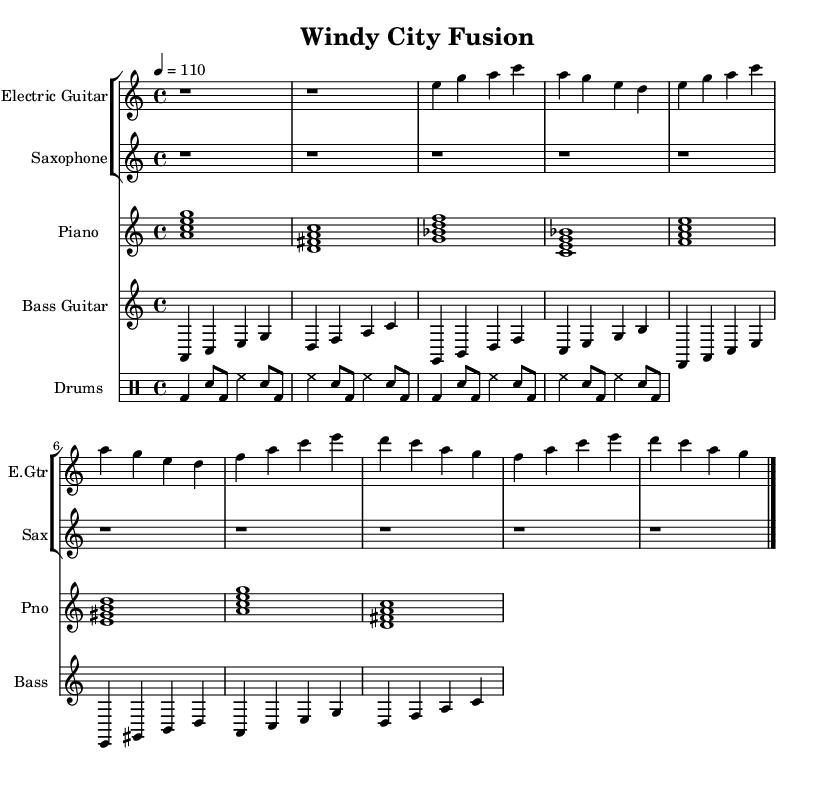What is the key signature of this music? The key signature is A minor, which is represented in the sheet music with no sharps or flats. It can be identified by looking at the global settings at the beginning of the code where it states " \key a \minor".
Answer: A minor What is the time signature of this music? The time signature is 4/4, indicated by " \time 4/4" in the global setup. This means there are four beats in each measure and the quarter note gets one beat.
Answer: 4/4 What is the tempo of this piece? The tempo is marked at 110 beats per minute, shown as " \tempo 4 = 110" in the code. This indicates a moderately fast pace for the music.
Answer: 110 How many measures are there in the electric guitar part? The electric guitar part consists of four measures in both the verse and chorus sections, totaling eight measures. The sections are clearly marked in the code and each measure is divided accordingly.
Answer: 8 What type of chord progression is used in the piano part? The piano part features a mix of minor and dominant seventh chords as indicated in the chord mode section of the code: a minor 7th, d dominant 7th, g minor 7th, and c dominant 7th. This is characteristic of blues music, as it provides depth and texture.
Answer: Minor and dominant seventh chords Which instrument plays the walking bass line? The bass guitar part plays the walking bass line, which is specifically designed to create a continuous and flowing rhythm throughout the piece. This is illustrated in the relative notation for the bass guitar part in the music.
Answer: Bass guitar What rhythmic pattern is employed in the drums? The drums use a basic blues shuffle pattern, indicated in the drummode section of the code. This pattern involves a combination of bass drum and snare hits that create a syncopated feel typical of the blues genre.
Answer: Blues shuffle pattern 